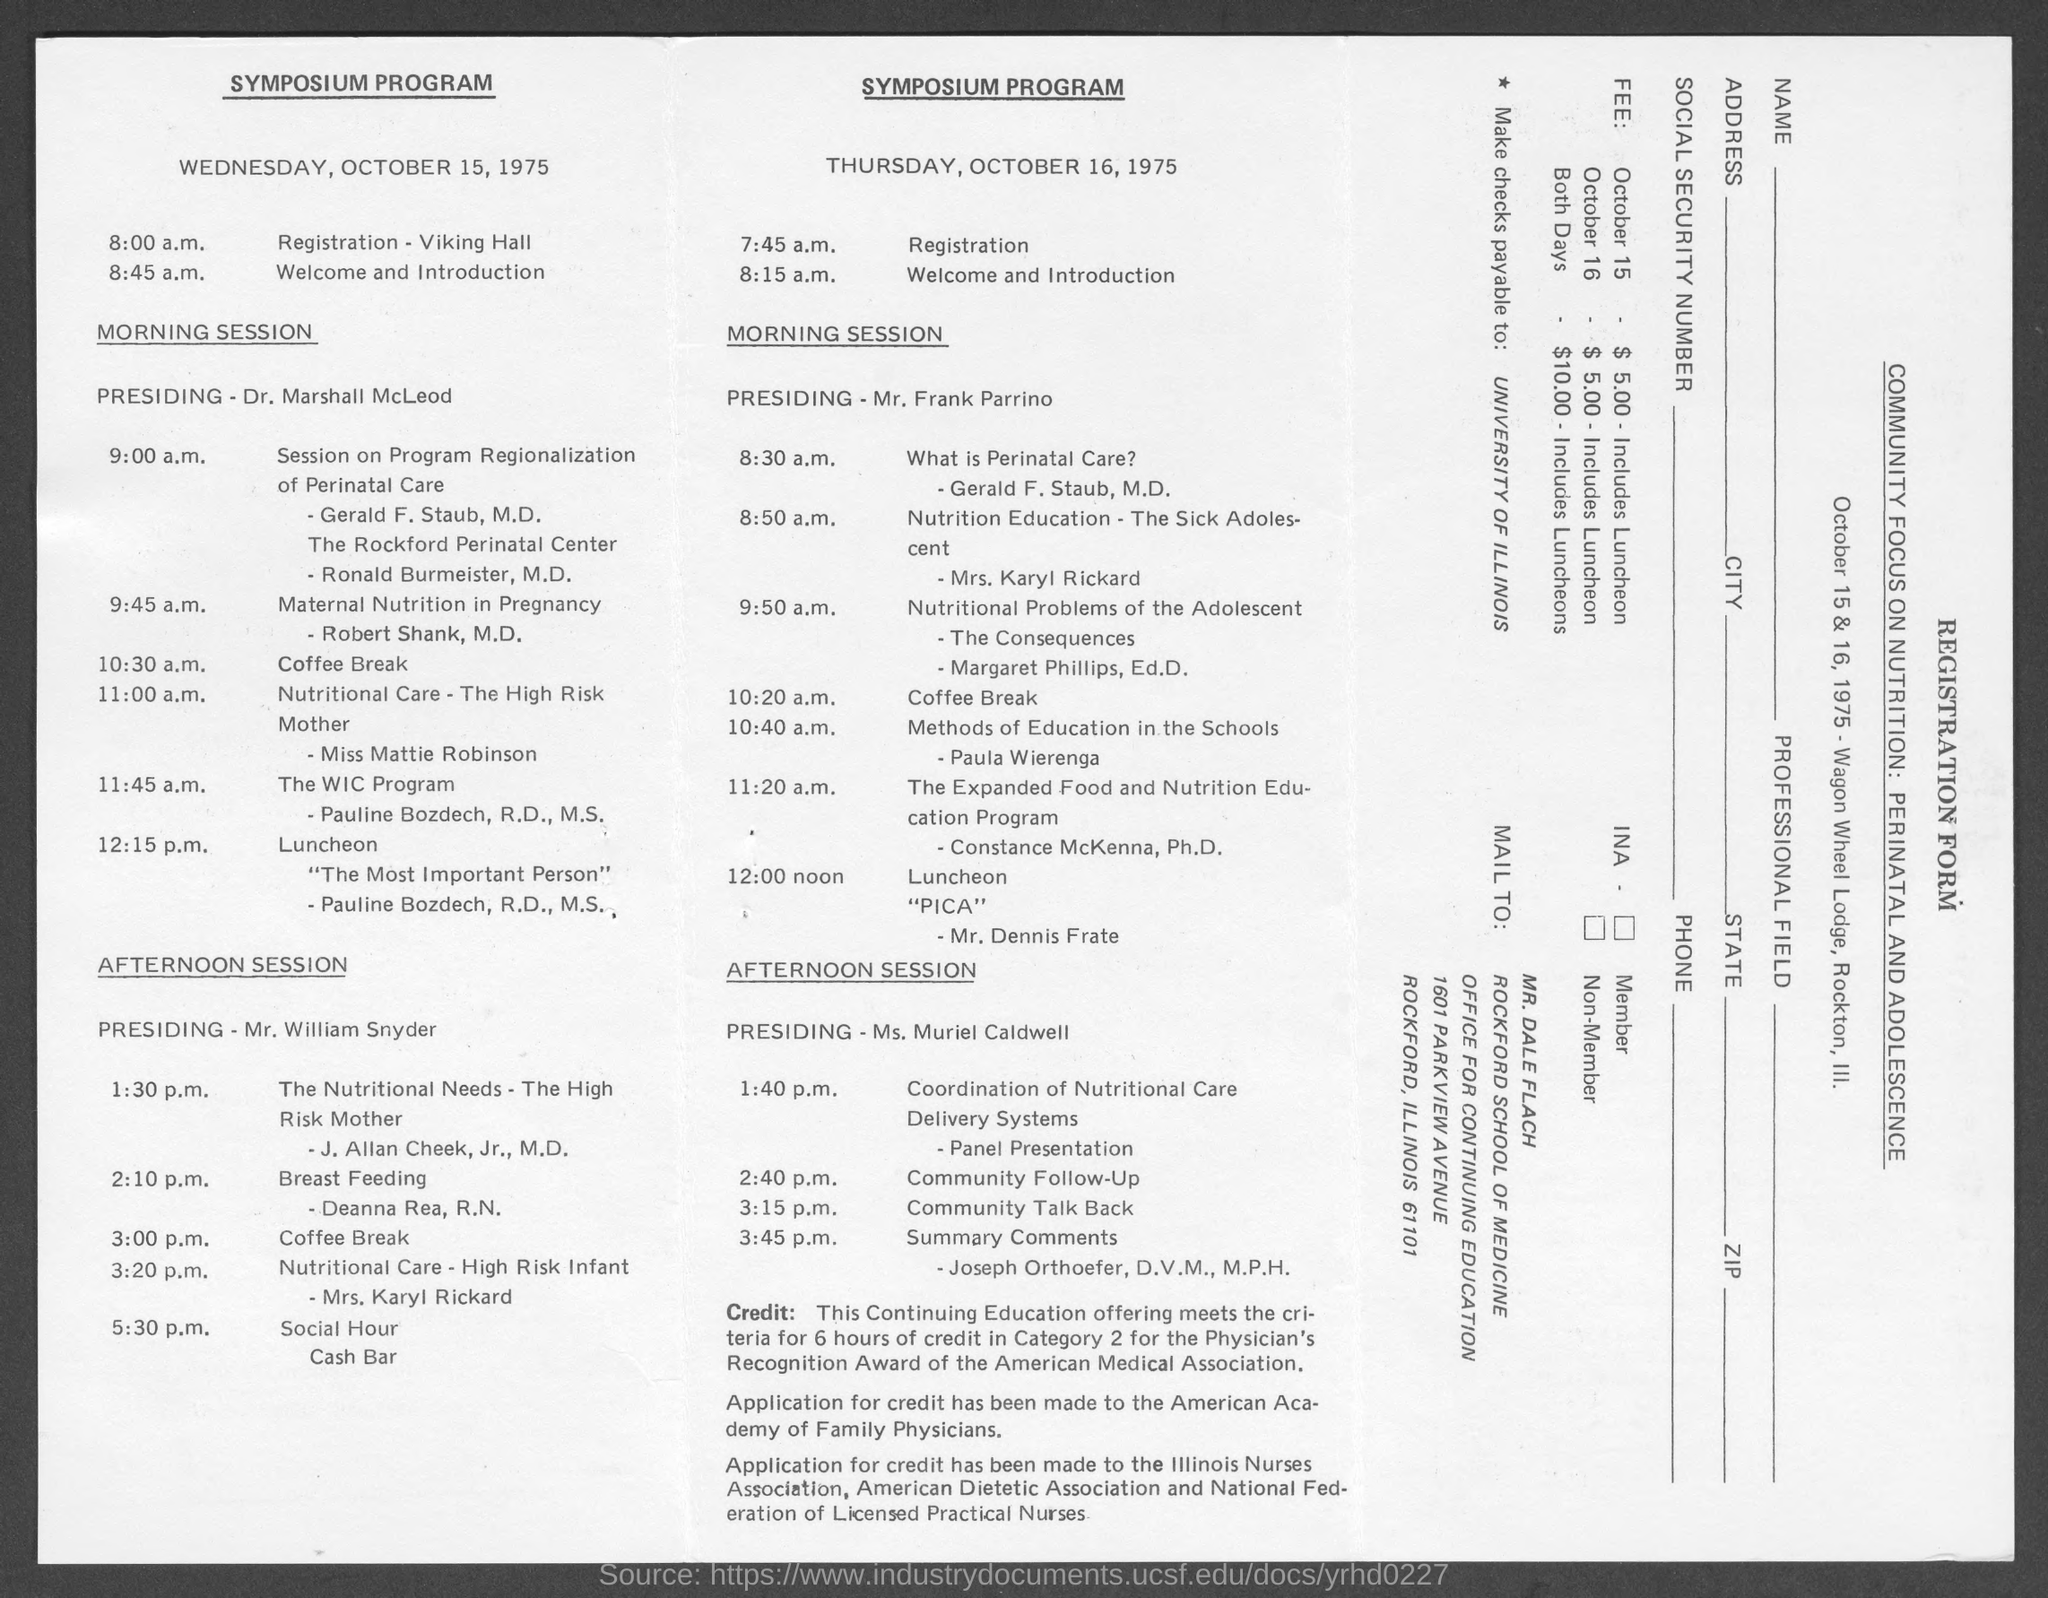Give some essential details in this illustration. The summary comments were made on Thursday, October 16, 1975 at 3:45 p.m. The registration took place on Thursday, October 16, 1975 at 7:45 a.m. On Wednesday, October 15, 1975, Mr. William Snyder was presiding over the afternoon session. On October 16, 1975, Mr. Frank Parrino presided over the morning session. On Thursday, October 16, 1975, the Welcome and Introduction occurred at 8:15 a.m. 